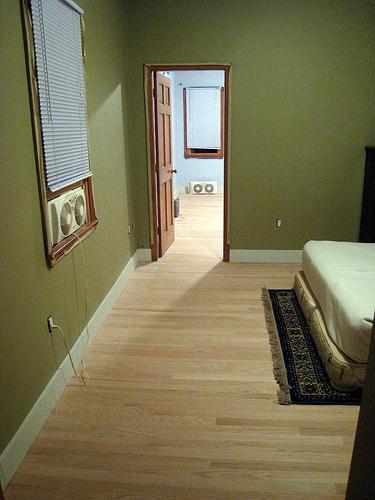How many windows are in the picture?
Give a very brief answer. 2. 